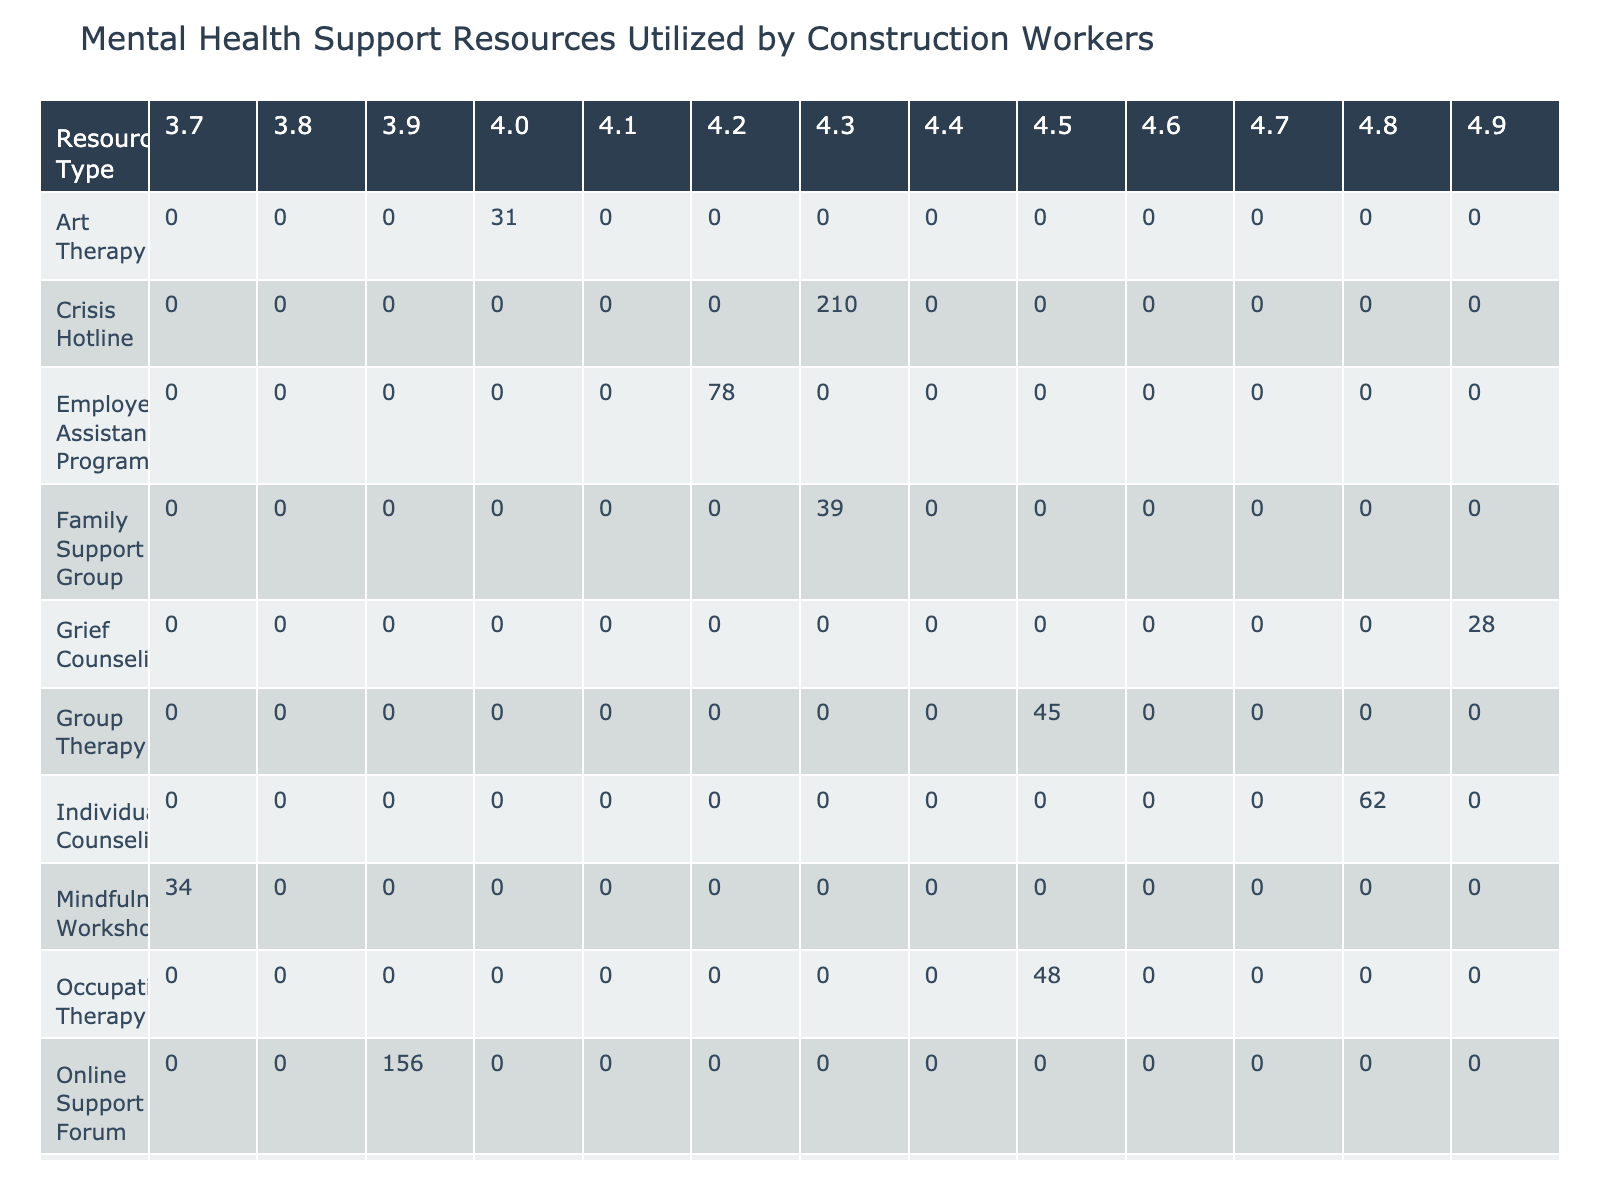What is the total number of users for the Crisis Hotline? The Crisis Hotline is listed in the table under the Resource Type column, with a corresponding Number of Users value of 210.
Answer: 210 Which resource type has the highest effectiveness rating? Examining the Effectiveness Rating column, the highest value is 4.9, which corresponds to Grief Counseling.
Answer: Grief Counseling How many users utilized online support resources (Online Support Forum and Crisis Hotline)? To find this, we sum the Number of Users for both Online Support Forum (156) and Crisis Hotline (210). Adding those gives 366 (156+210).
Answer: 366 Is the Peer Support Program considered to have a high anonymity level? The table indicates the anonymity level for the Peer Support Program is 'Low', which means it does not provide high anonymity.
Answer: No What is the average effectiveness rating for resources with a high anonymity level? First, we identify the resources with a high anonymity level: Individual Counseling (4.8), Online Support Forum (3.9), Crisis Hotline (4.3), and PTSD Treatment (4.7). Adding these ratings gives 19.7 (4.8 + 3.9 + 4.3 + 4.7). Dividing by 4 (the number of resources) gives an average of 4.925, which can be rounded to 4.9.
Answer: 4.9 How does the effectiveness rating of Group Therapy compare to that of Mindfulness Workshop? Group Therapy has an effectiveness rating of 4.5, while Mindfulness Workshop has a rating of 3.7. Comparing these shows that Group Therapy is rated higher than Mindfulness Workshop by 0.8 (4.5-3.7).
Answer: Group Therapy is higher by 0.8 Which resource had the lowest cost per session? By reviewing the Cost per Session column, we see that the Employee Assistance Program, Peer Support Program, and Online Support Forum have a cost of 0 per session, making them the lowest.
Answer: Employee Assistance Program, Peer Support Program, Online Support Forum How many users utilized individual mental health services (Individual Counseling, Grief Counseling, and PTSD Treatment)? We add the Number of Users for each of these categories: Individual Counseling (62), Grief Counseling (28), and PTSD Treatment (53). Adding these together gives a total of 143 (62+28+53).
Answer: 143 